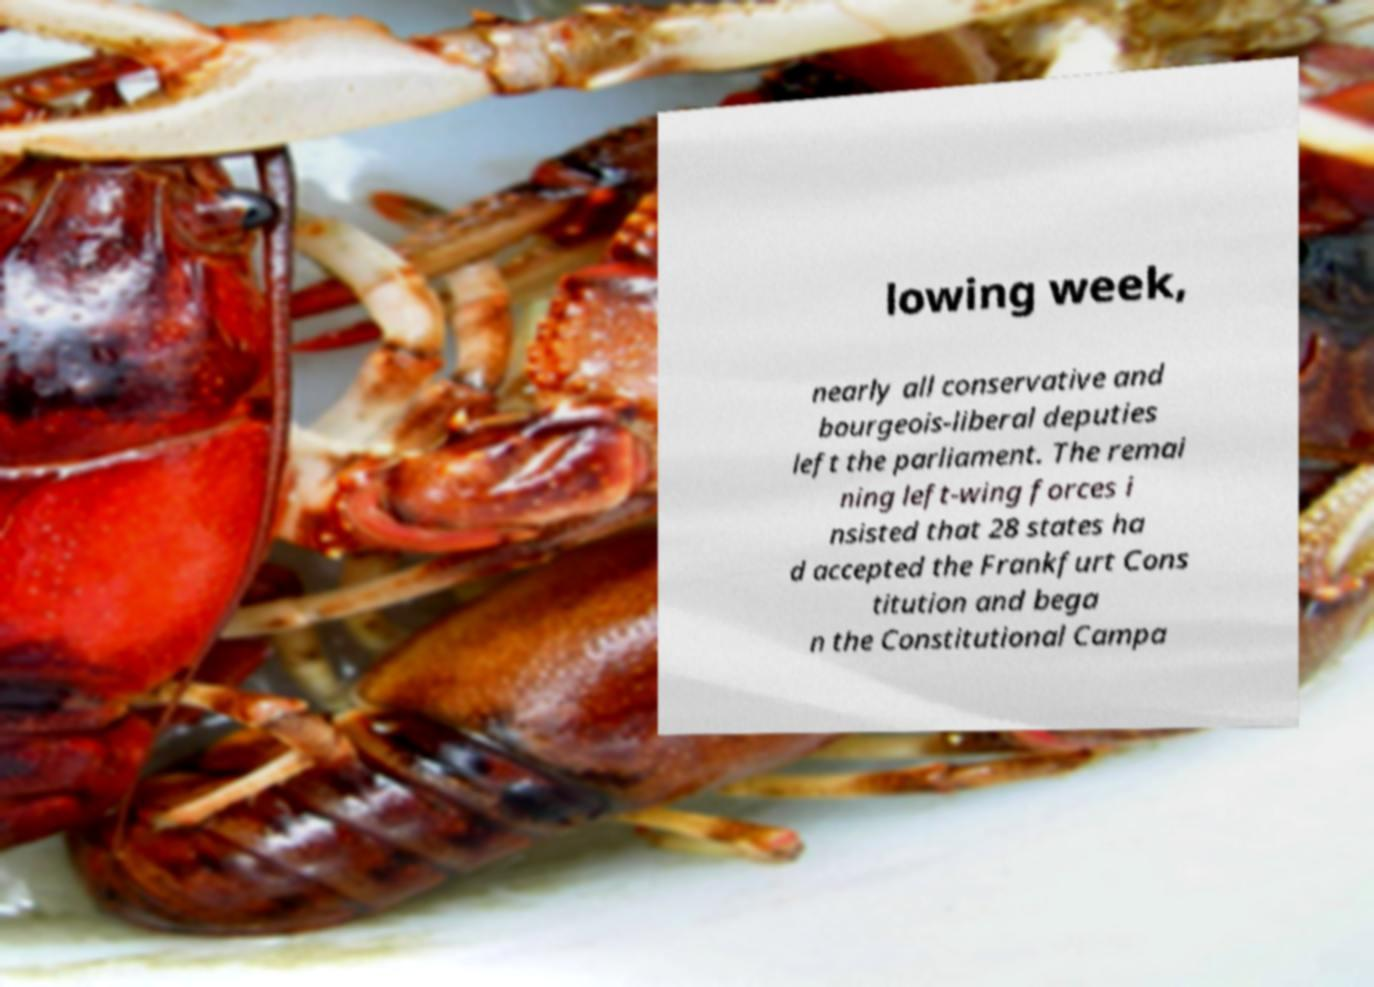There's text embedded in this image that I need extracted. Can you transcribe it verbatim? lowing week, nearly all conservative and bourgeois-liberal deputies left the parliament. The remai ning left-wing forces i nsisted that 28 states ha d accepted the Frankfurt Cons titution and bega n the Constitutional Campa 